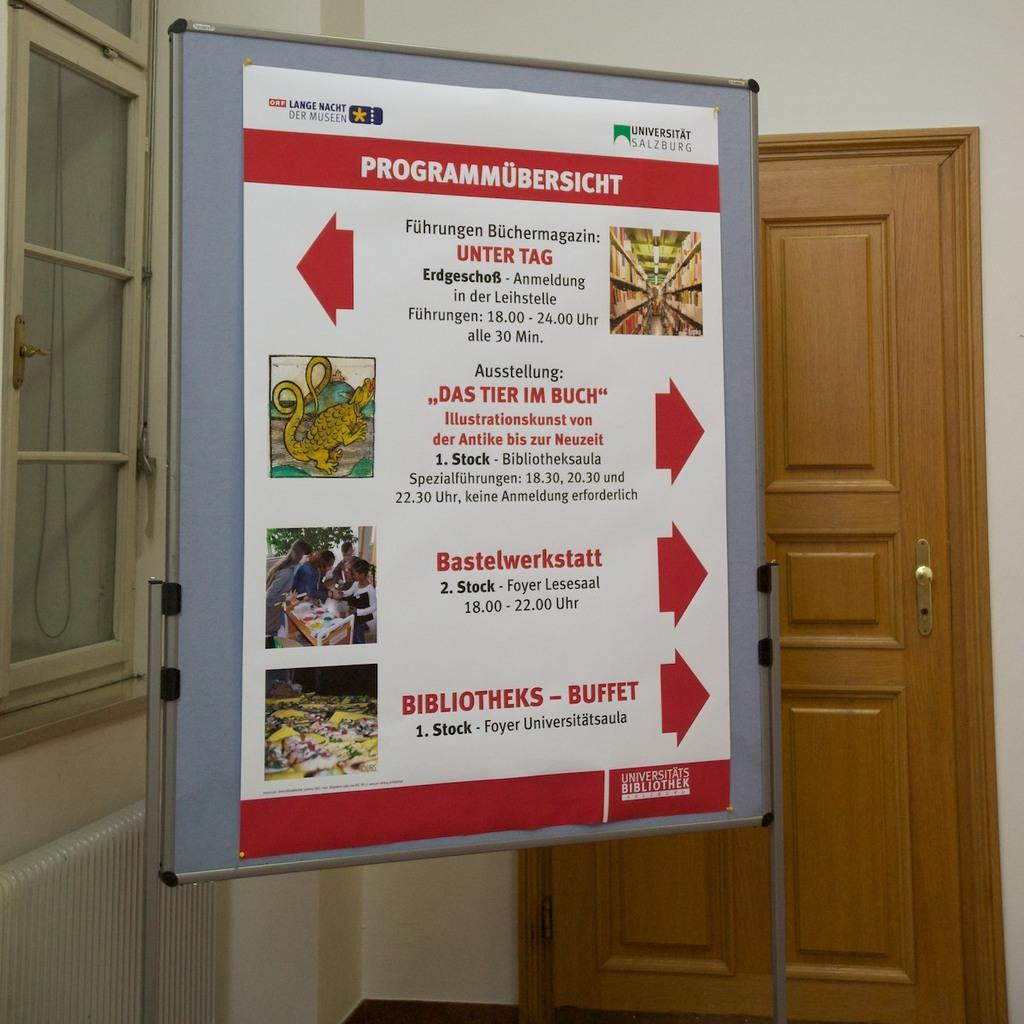<image>
Summarize the visual content of the image. Sign next to a door that says "Programmubersicht" on the top. 